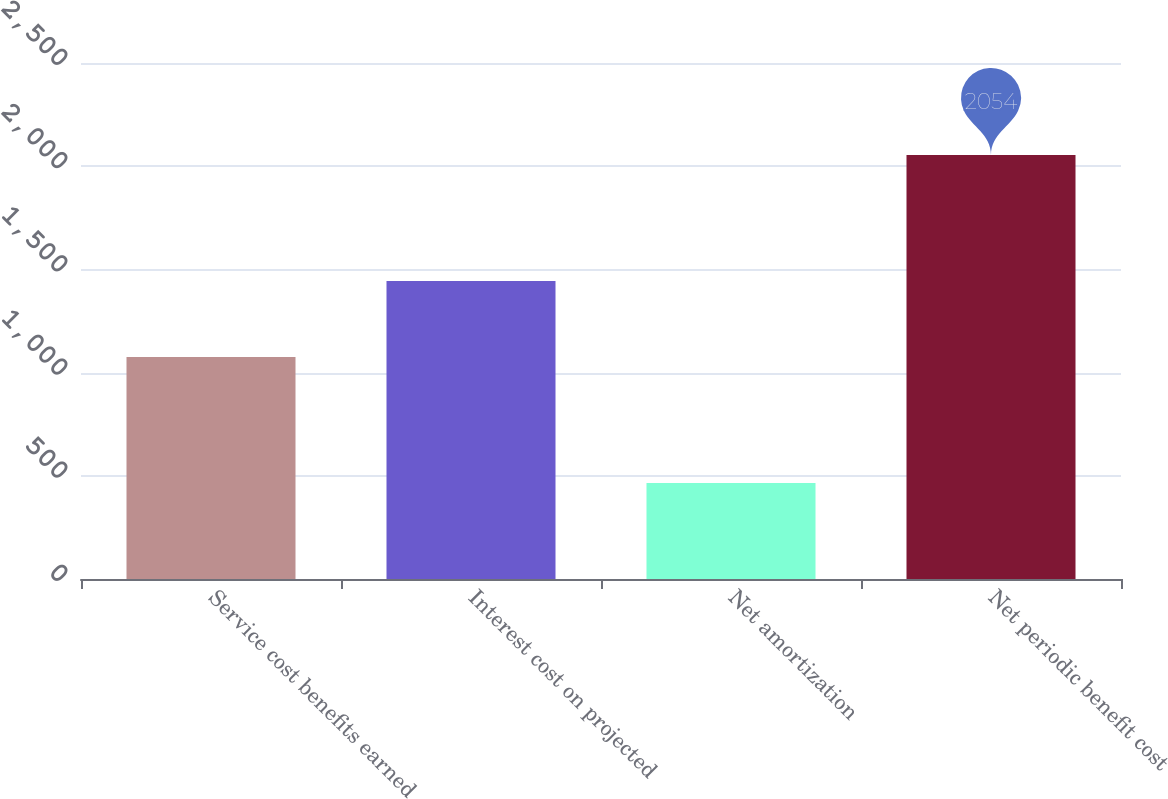<chart> <loc_0><loc_0><loc_500><loc_500><bar_chart><fcel>Service cost benefits earned<fcel>Interest cost on projected<fcel>Net amortization<fcel>Net periodic benefit cost<nl><fcel>1075<fcel>1444<fcel>465<fcel>2054<nl></chart> 